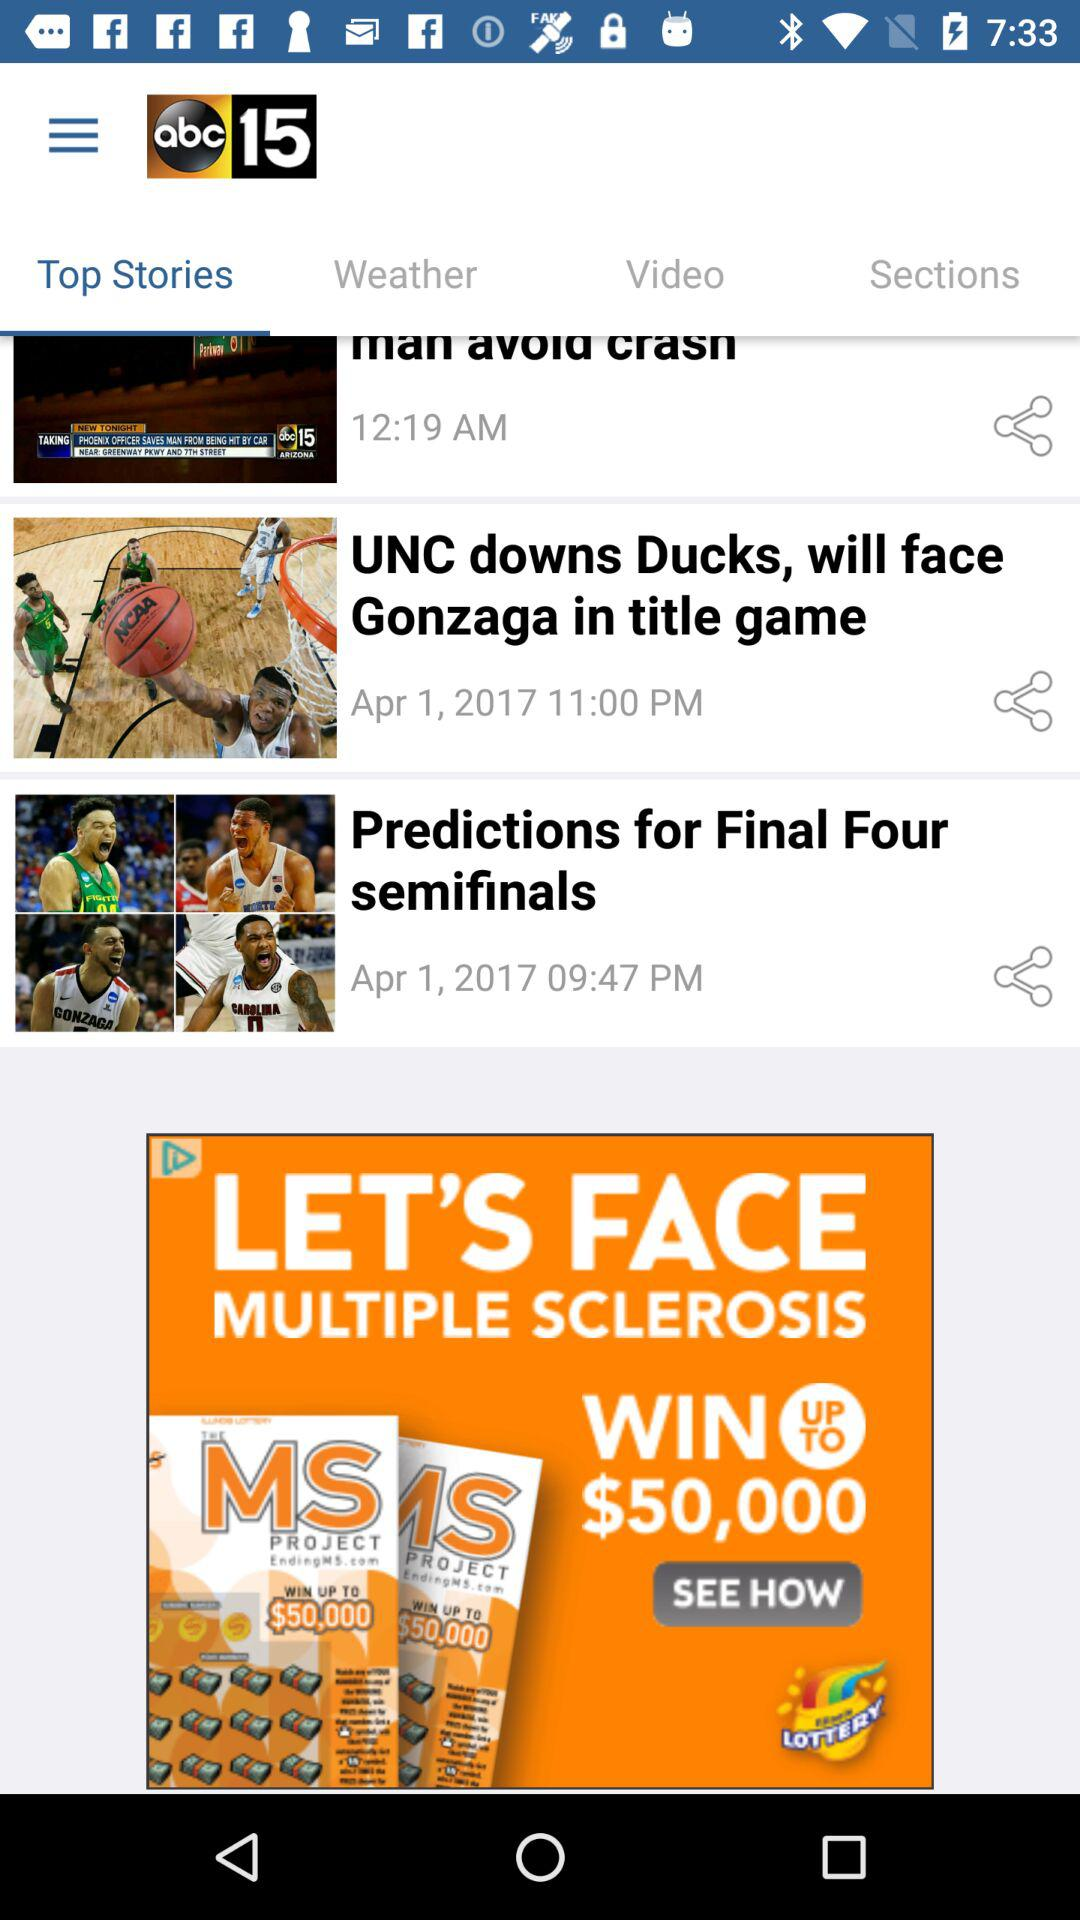What is the application name? The application name is "ABC15". 